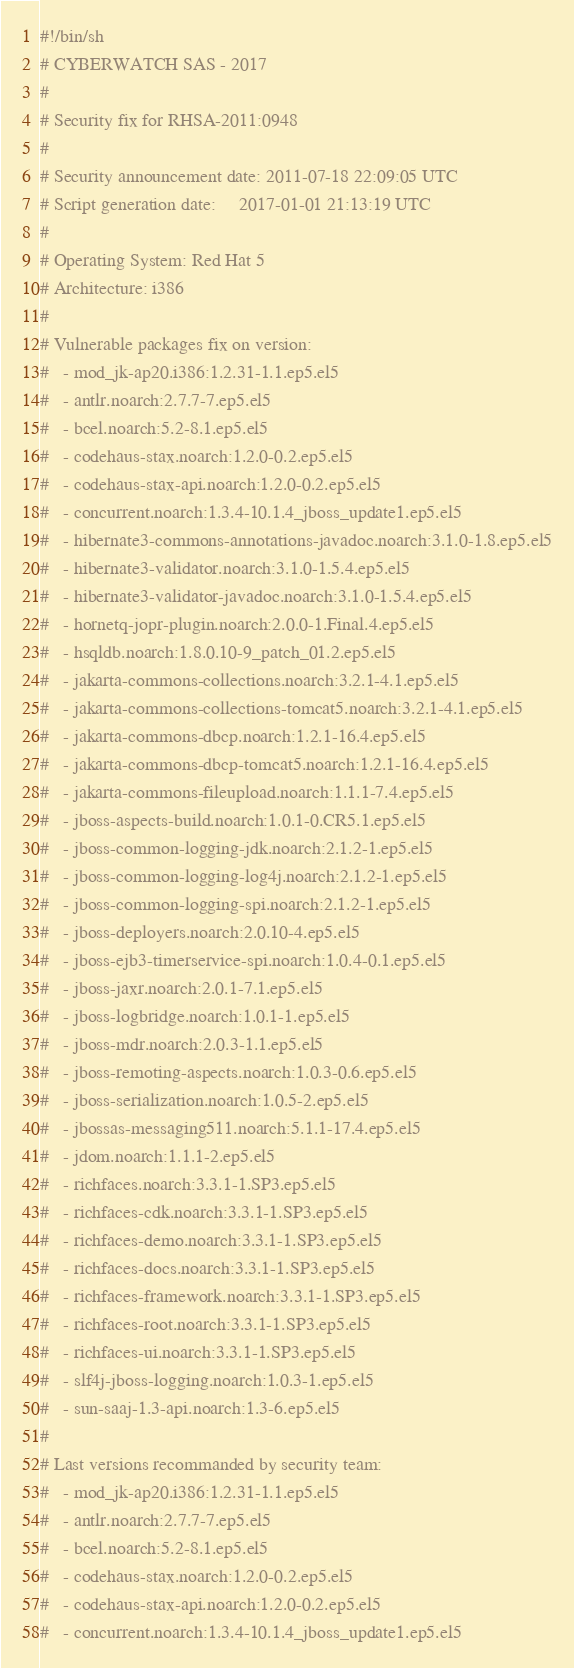<code> <loc_0><loc_0><loc_500><loc_500><_Bash_>#!/bin/sh
# CYBERWATCH SAS - 2017
#
# Security fix for RHSA-2011:0948
#
# Security announcement date: 2011-07-18 22:09:05 UTC
# Script generation date:     2017-01-01 21:13:19 UTC
#
# Operating System: Red Hat 5
# Architecture: i386
#
# Vulnerable packages fix on version:
#   - mod_jk-ap20.i386:1.2.31-1.1.ep5.el5
#   - antlr.noarch:2.7.7-7.ep5.el5
#   - bcel.noarch:5.2-8.1.ep5.el5
#   - codehaus-stax.noarch:1.2.0-0.2.ep5.el5
#   - codehaus-stax-api.noarch:1.2.0-0.2.ep5.el5
#   - concurrent.noarch:1.3.4-10.1.4_jboss_update1.ep5.el5
#   - hibernate3-commons-annotations-javadoc.noarch:3.1.0-1.8.ep5.el5
#   - hibernate3-validator.noarch:3.1.0-1.5.4.ep5.el5
#   - hibernate3-validator-javadoc.noarch:3.1.0-1.5.4.ep5.el5
#   - hornetq-jopr-plugin.noarch:2.0.0-1.Final.4.ep5.el5
#   - hsqldb.noarch:1.8.0.10-9_patch_01.2.ep5.el5
#   - jakarta-commons-collections.noarch:3.2.1-4.1.ep5.el5
#   - jakarta-commons-collections-tomcat5.noarch:3.2.1-4.1.ep5.el5
#   - jakarta-commons-dbcp.noarch:1.2.1-16.4.ep5.el5
#   - jakarta-commons-dbcp-tomcat5.noarch:1.2.1-16.4.ep5.el5
#   - jakarta-commons-fileupload.noarch:1.1.1-7.4.ep5.el5
#   - jboss-aspects-build.noarch:1.0.1-0.CR5.1.ep5.el5
#   - jboss-common-logging-jdk.noarch:2.1.2-1.ep5.el5
#   - jboss-common-logging-log4j.noarch:2.1.2-1.ep5.el5
#   - jboss-common-logging-spi.noarch:2.1.2-1.ep5.el5
#   - jboss-deployers.noarch:2.0.10-4.ep5.el5
#   - jboss-ejb3-timerservice-spi.noarch:1.0.4-0.1.ep5.el5
#   - jboss-jaxr.noarch:2.0.1-7.1.ep5.el5
#   - jboss-logbridge.noarch:1.0.1-1.ep5.el5
#   - jboss-mdr.noarch:2.0.3-1.1.ep5.el5
#   - jboss-remoting-aspects.noarch:1.0.3-0.6.ep5.el5
#   - jboss-serialization.noarch:1.0.5-2.ep5.el5
#   - jbossas-messaging511.noarch:5.1.1-17.4.ep5.el5
#   - jdom.noarch:1.1.1-2.ep5.el5
#   - richfaces.noarch:3.3.1-1.SP3.ep5.el5
#   - richfaces-cdk.noarch:3.3.1-1.SP3.ep5.el5
#   - richfaces-demo.noarch:3.3.1-1.SP3.ep5.el5
#   - richfaces-docs.noarch:3.3.1-1.SP3.ep5.el5
#   - richfaces-framework.noarch:3.3.1-1.SP3.ep5.el5
#   - richfaces-root.noarch:3.3.1-1.SP3.ep5.el5
#   - richfaces-ui.noarch:3.3.1-1.SP3.ep5.el5
#   - slf4j-jboss-logging.noarch:1.0.3-1.ep5.el5
#   - sun-saaj-1.3-api.noarch:1.3-6.ep5.el5
#
# Last versions recommanded by security team:
#   - mod_jk-ap20.i386:1.2.31-1.1.ep5.el5
#   - antlr.noarch:2.7.7-7.ep5.el5
#   - bcel.noarch:5.2-8.1.ep5.el5
#   - codehaus-stax.noarch:1.2.0-0.2.ep5.el5
#   - codehaus-stax-api.noarch:1.2.0-0.2.ep5.el5
#   - concurrent.noarch:1.3.4-10.1.4_jboss_update1.ep5.el5</code> 